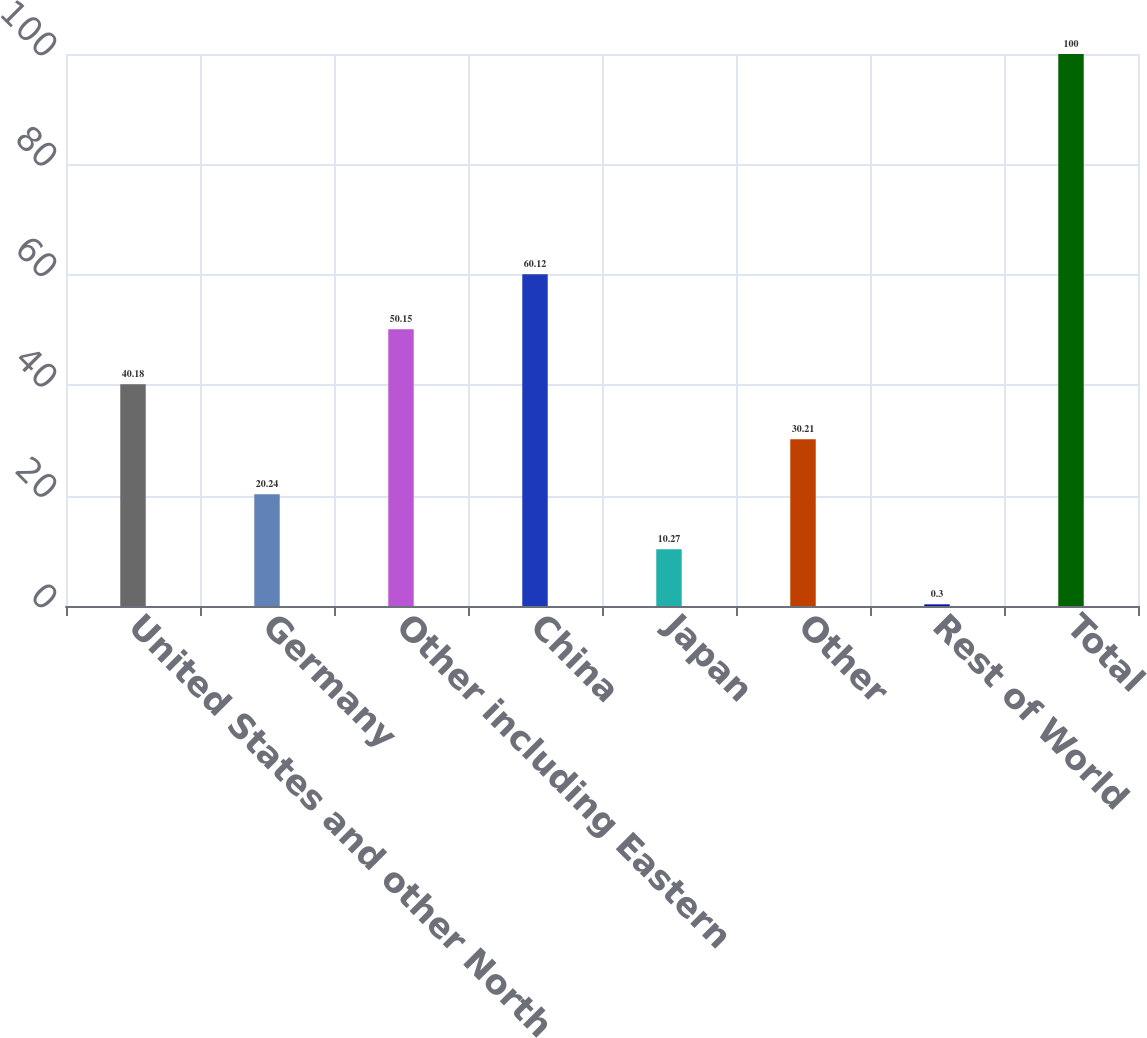Convert chart to OTSL. <chart><loc_0><loc_0><loc_500><loc_500><bar_chart><fcel>United States and other North<fcel>Germany<fcel>Other including Eastern<fcel>China<fcel>Japan<fcel>Other<fcel>Rest of World<fcel>Total<nl><fcel>40.18<fcel>20.24<fcel>50.15<fcel>60.12<fcel>10.27<fcel>30.21<fcel>0.3<fcel>100<nl></chart> 